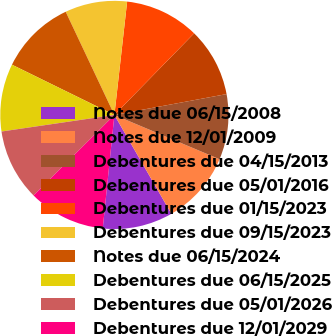Convert chart. <chart><loc_0><loc_0><loc_500><loc_500><pie_chart><fcel>Notes due 06/15/2008<fcel>Notes due 12/01/2009<fcel>Debentures due 04/15/2013<fcel>Debentures due 05/01/2016<fcel>Debentures due 01/15/2023<fcel>Debentures due 09/15/2023<fcel>Notes due 06/15/2024<fcel>Debentures due 06/15/2025<fcel>Debentures due 05/01/2026<fcel>Debentures due 12/01/2029<nl><fcel>9.95%<fcel>10.33%<fcel>9.27%<fcel>9.76%<fcel>10.53%<fcel>8.8%<fcel>10.72%<fcel>9.58%<fcel>10.14%<fcel>10.91%<nl></chart> 